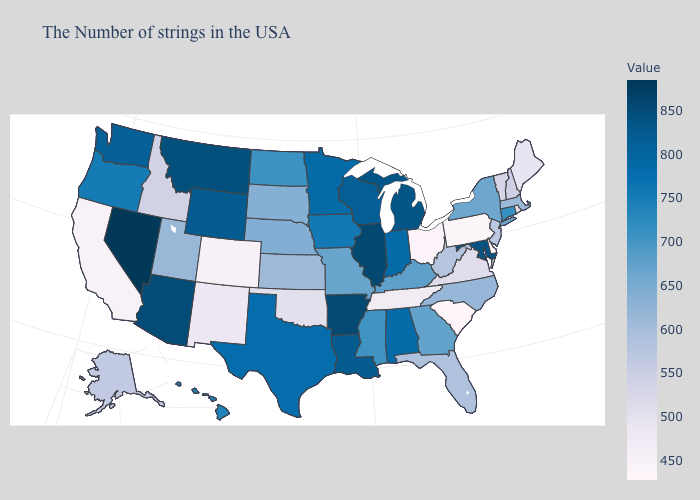Among the states that border Pennsylvania , does New Jersey have the highest value?
Be succinct. No. Does Iowa have a lower value than California?
Answer briefly. No. Does New York have a lower value than Virginia?
Write a very short answer. No. Among the states that border South Dakota , does North Dakota have the lowest value?
Give a very brief answer. No. Among the states that border Alabama , does Florida have the lowest value?
Short answer required. No. Does Massachusetts have the lowest value in the Northeast?
Concise answer only. No. Does the map have missing data?
Answer briefly. No. Among the states that border Vermont , which have the lowest value?
Keep it brief. New Hampshire. 